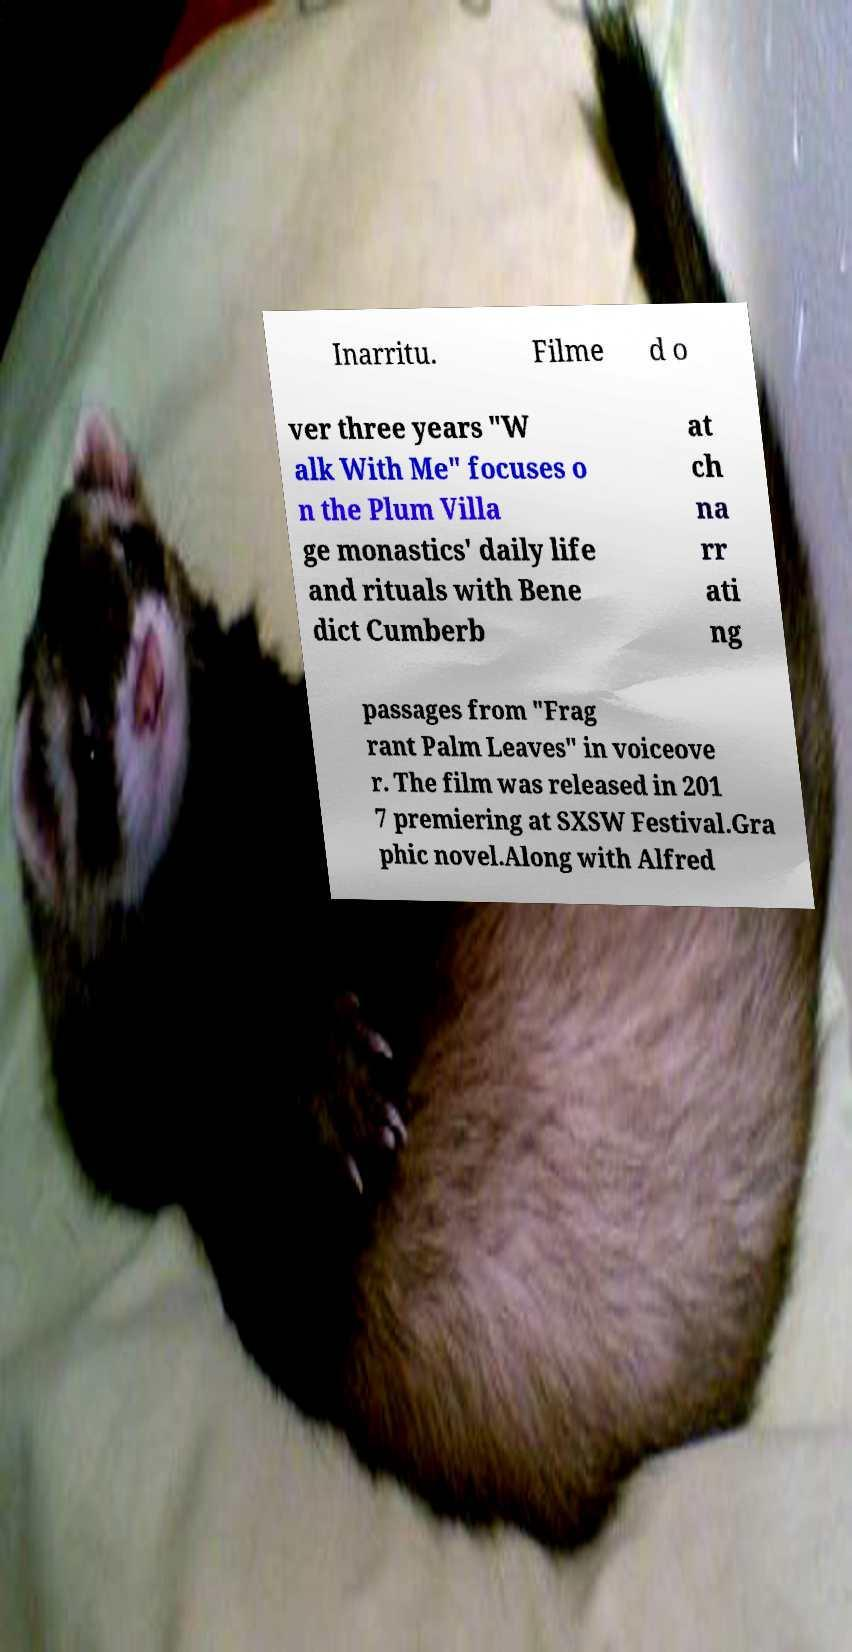Can you read and provide the text displayed in the image?This photo seems to have some interesting text. Can you extract and type it out for me? Inarritu. Filme d o ver three years "W alk With Me" focuses o n the Plum Villa ge monastics' daily life and rituals with Bene dict Cumberb at ch na rr ati ng passages from "Frag rant Palm Leaves" in voiceove r. The film was released in 201 7 premiering at SXSW Festival.Gra phic novel.Along with Alfred 